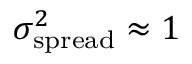<formula> <loc_0><loc_0><loc_500><loc_500>\sigma _ { s p r e a d } ^ { 2 } \approx 1</formula> 